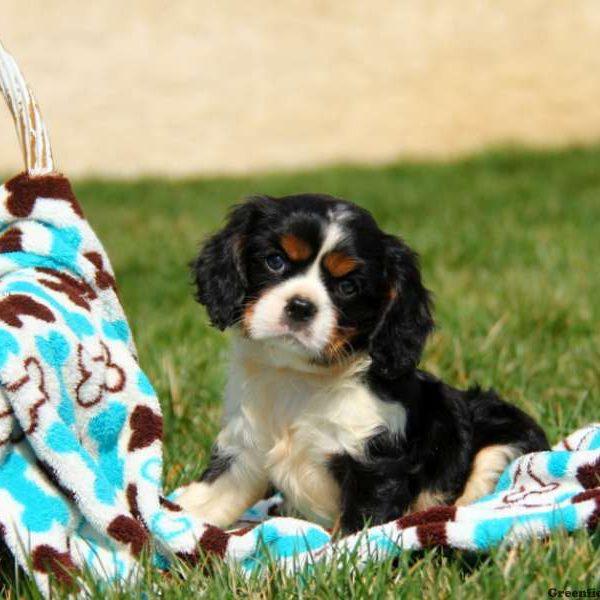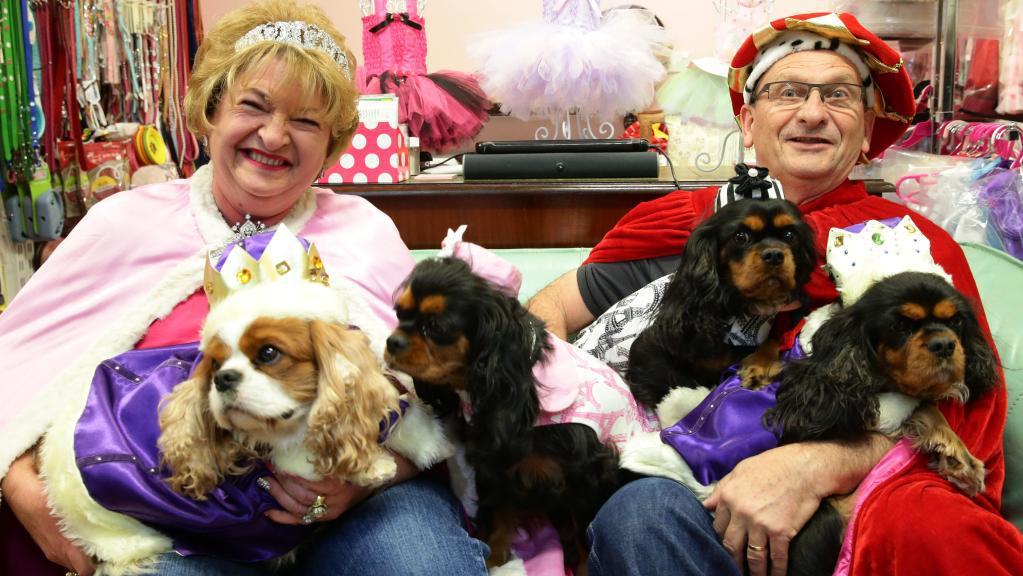The first image is the image on the left, the second image is the image on the right. For the images displayed, is the sentence "There are two dogs." factually correct? Answer yes or no. No. The first image is the image on the left, the second image is the image on the right. Analyze the images presented: Is the assertion "Two or more dogs are being held by one or more humans in one of the images." valid? Answer yes or no. Yes. 